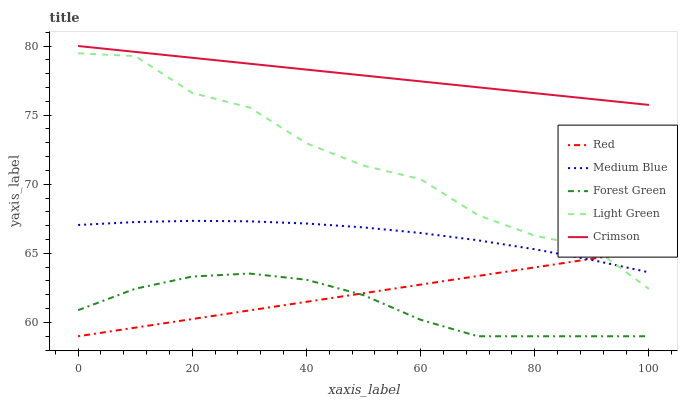Does Forest Green have the minimum area under the curve?
Answer yes or no. Yes. Does Crimson have the maximum area under the curve?
Answer yes or no. Yes. Does Medium Blue have the minimum area under the curve?
Answer yes or no. No. Does Medium Blue have the maximum area under the curve?
Answer yes or no. No. Is Red the smoothest?
Answer yes or no. Yes. Is Light Green the roughest?
Answer yes or no. Yes. Is Forest Green the smoothest?
Answer yes or no. No. Is Forest Green the roughest?
Answer yes or no. No. Does Forest Green have the lowest value?
Answer yes or no. Yes. Does Medium Blue have the lowest value?
Answer yes or no. No. Does Crimson have the highest value?
Answer yes or no. Yes. Does Medium Blue have the highest value?
Answer yes or no. No. Is Forest Green less than Crimson?
Answer yes or no. Yes. Is Crimson greater than Red?
Answer yes or no. Yes. Does Red intersect Medium Blue?
Answer yes or no. Yes. Is Red less than Medium Blue?
Answer yes or no. No. Is Red greater than Medium Blue?
Answer yes or no. No. Does Forest Green intersect Crimson?
Answer yes or no. No. 